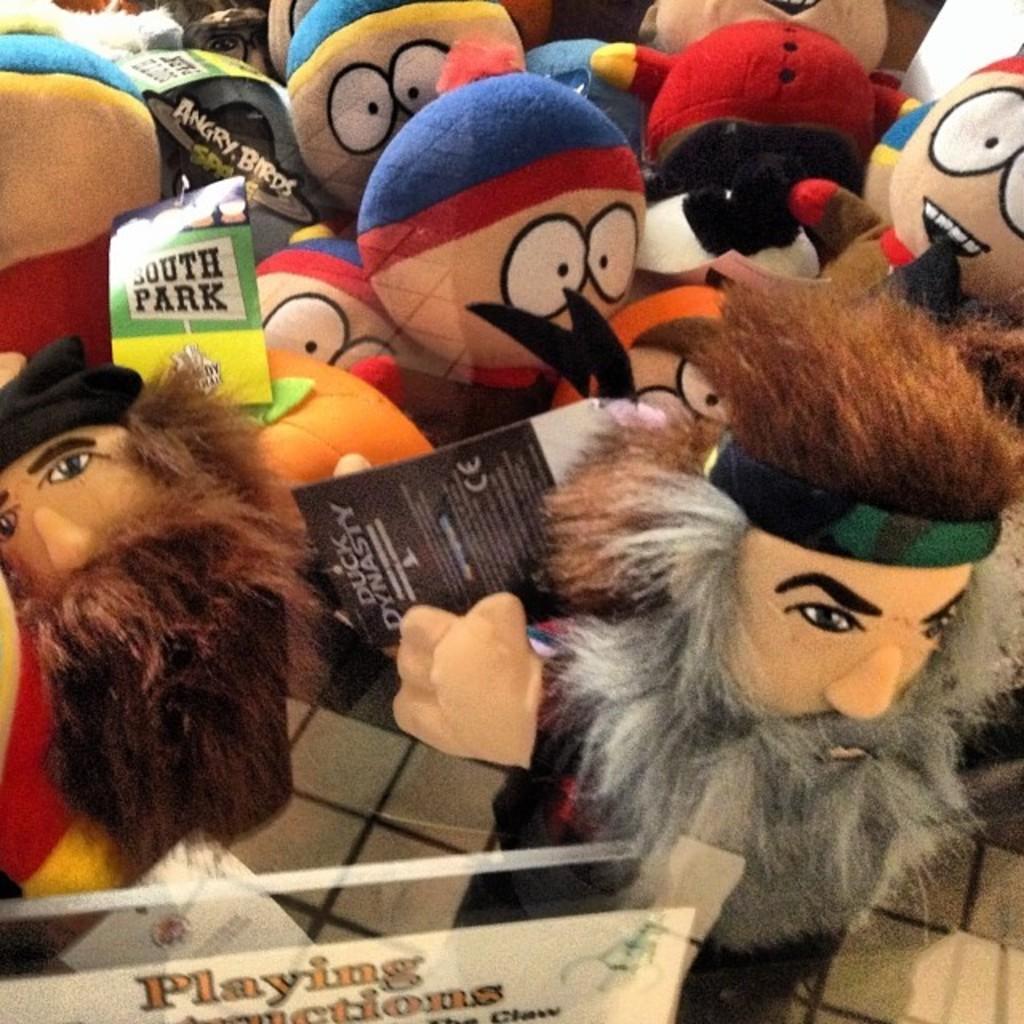Could you give a brief overview of what you see in this image? In this picture there are toys and there are boards and there is text on the boards. At the bottom it looks like a floor. 